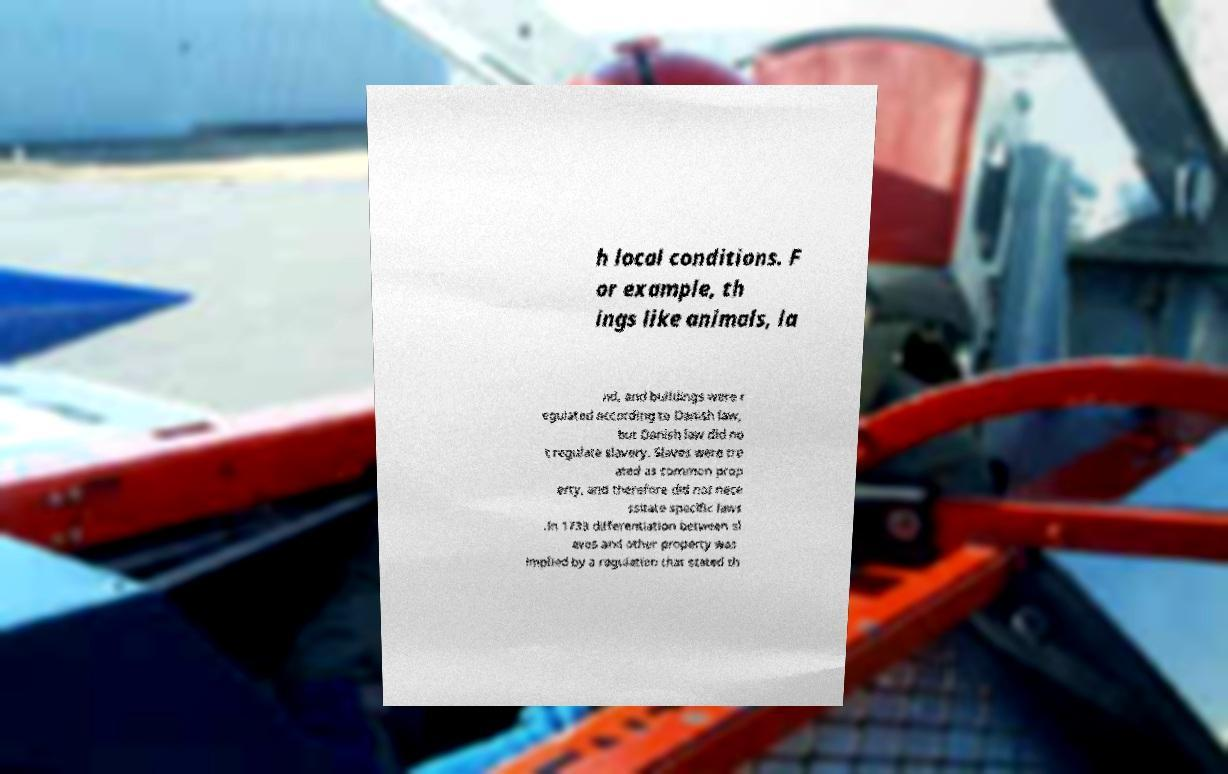Can you read and provide the text displayed in the image?This photo seems to have some interesting text. Can you extract and type it out for me? h local conditions. F or example, th ings like animals, la nd, and buildings were r egulated according to Danish law, but Danish law did no t regulate slavery. Slaves were tre ated as common prop erty, and therefore did not nece ssitate specific laws .In 1733 differentiation between sl aves and other property was implied by a regulation that stated th 